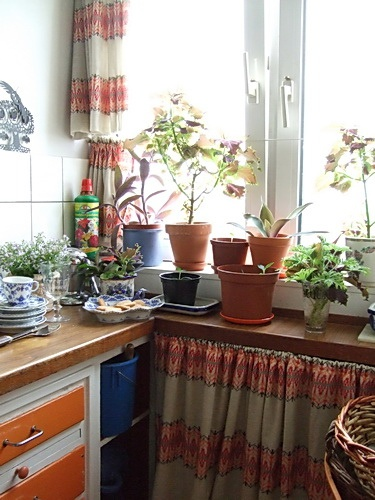Describe the objects in this image and their specific colors. I can see potted plant in white, ivory, beige, darkgray, and tan tones, potted plant in white, darkgreen, black, gray, and olive tones, potted plant in white, maroon, black, gray, and brown tones, potted plant in white, ivory, darkgray, beige, and gray tones, and potted plant in white, gray, and darkgray tones in this image. 